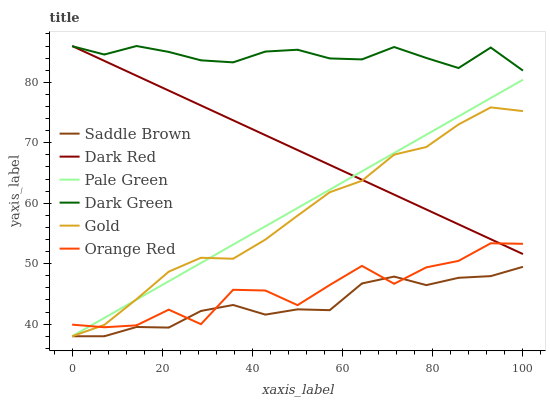Does Saddle Brown have the minimum area under the curve?
Answer yes or no. Yes. Does Dark Green have the maximum area under the curve?
Answer yes or no. Yes. Does Dark Red have the minimum area under the curve?
Answer yes or no. No. Does Dark Red have the maximum area under the curve?
Answer yes or no. No. Is Pale Green the smoothest?
Answer yes or no. Yes. Is Orange Red the roughest?
Answer yes or no. Yes. Is Dark Red the smoothest?
Answer yes or no. No. Is Dark Red the roughest?
Answer yes or no. No. Does Gold have the lowest value?
Answer yes or no. Yes. Does Dark Red have the lowest value?
Answer yes or no. No. Does Dark Green have the highest value?
Answer yes or no. Yes. Does Saddle Brown have the highest value?
Answer yes or no. No. Is Saddle Brown less than Dark Green?
Answer yes or no. Yes. Is Dark Green greater than Pale Green?
Answer yes or no. Yes. Does Dark Red intersect Gold?
Answer yes or no. Yes. Is Dark Red less than Gold?
Answer yes or no. No. Is Dark Red greater than Gold?
Answer yes or no. No. Does Saddle Brown intersect Dark Green?
Answer yes or no. No. 